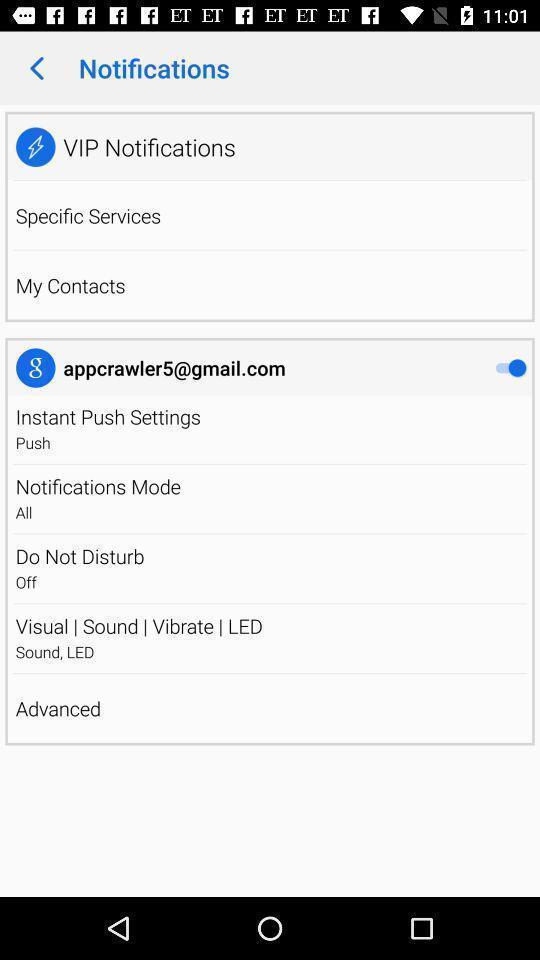Summarize the information in this screenshot. Screen displays notifications on a device. 